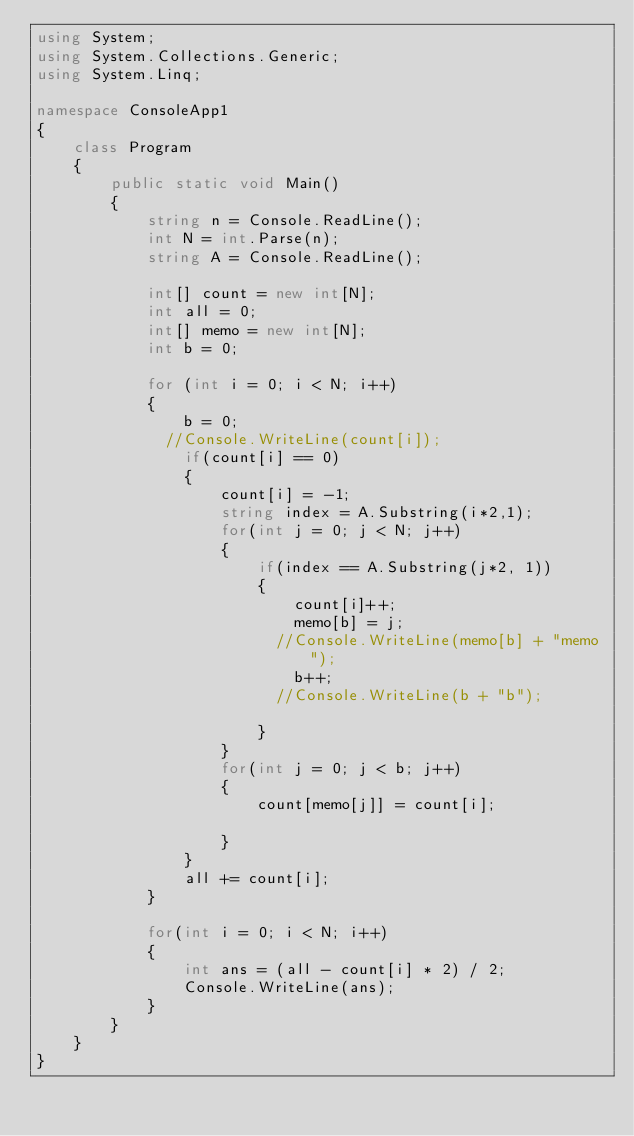Convert code to text. <code><loc_0><loc_0><loc_500><loc_500><_C#_>using System;
using System.Collections.Generic;
using System.Linq;

namespace ConsoleApp1
{
    class Program
    {
        public static void Main()
        {
            string n = Console.ReadLine();
            int N = int.Parse(n);
            string A = Console.ReadLine();

            int[] count = new int[N];
            int all = 0;
            int[] memo = new int[N];
            int b = 0;

            for (int i = 0; i < N; i++)
            {
                b = 0;
              //Console.WriteLine(count[i]);
                if(count[i] == 0)
                {
                    count[i] = -1;
                    string index = A.Substring(i*2,1);                    
                    for(int j = 0; j < N; j++)
                    {
                        if(index == A.Substring(j*2, 1))
                        {
                            count[i]++;                        
                            memo[b] = j;
                          //Console.WriteLine(memo[b] + "memo");
                            b++;
                          //Console.WriteLine(b + "b");
                          
                        }
                    }
                    for(int j = 0; j < b; j++)
                    {
                        count[memo[j]] = count[i];
                        
                    }
                }
                all += count[i];
            }
			
            for(int i = 0; i < N; i++)
            {
                int ans = (all - count[i] * 2) / 2;
                Console.WriteLine(ans);
            }
        }
    }
}</code> 